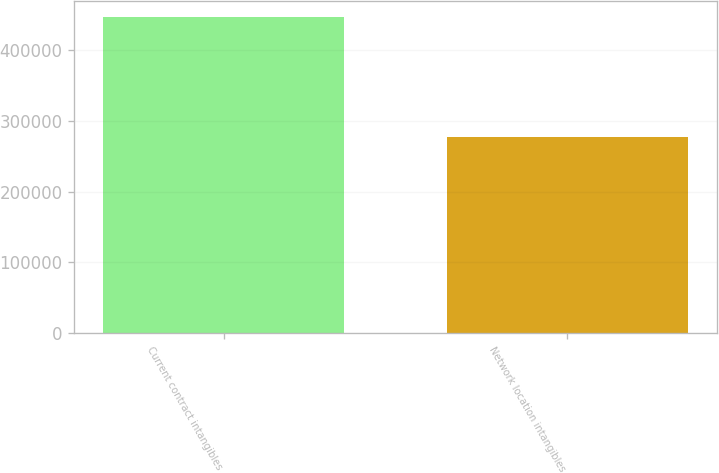Convert chart to OTSL. <chart><loc_0><loc_0><loc_500><loc_500><bar_chart><fcel>Current contract intangibles<fcel>Network location intangibles<nl><fcel>447156<fcel>277716<nl></chart> 